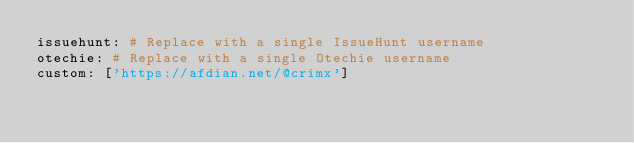Convert code to text. <code><loc_0><loc_0><loc_500><loc_500><_YAML_>issuehunt: # Replace with a single IssueHunt username
otechie: # Replace with a single Otechie username
custom: ['https://afdian.net/@crimx']
</code> 